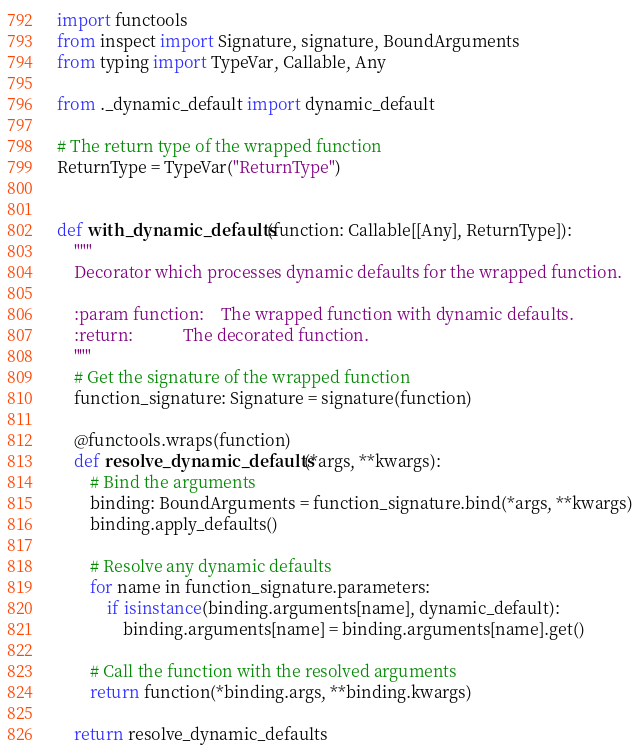Convert code to text. <code><loc_0><loc_0><loc_500><loc_500><_Python_>import functools
from inspect import Signature, signature, BoundArguments
from typing import TypeVar, Callable, Any

from ._dynamic_default import dynamic_default

# The return type of the wrapped function
ReturnType = TypeVar("ReturnType")


def with_dynamic_defaults(function: Callable[[Any], ReturnType]):
    """
    Decorator which processes dynamic defaults for the wrapped function.

    :param function:    The wrapped function with dynamic defaults.
    :return:            The decorated function.
    """
    # Get the signature of the wrapped function
    function_signature: Signature = signature(function)

    @functools.wraps(function)
    def resolve_dynamic_defaults(*args, **kwargs):
        # Bind the arguments
        binding: BoundArguments = function_signature.bind(*args, **kwargs)
        binding.apply_defaults()

        # Resolve any dynamic defaults
        for name in function_signature.parameters:
            if isinstance(binding.arguments[name], dynamic_default):
                binding.arguments[name] = binding.arguments[name].get()

        # Call the function with the resolved arguments
        return function(*binding.args, **binding.kwargs)

    return resolve_dynamic_defaults
</code> 